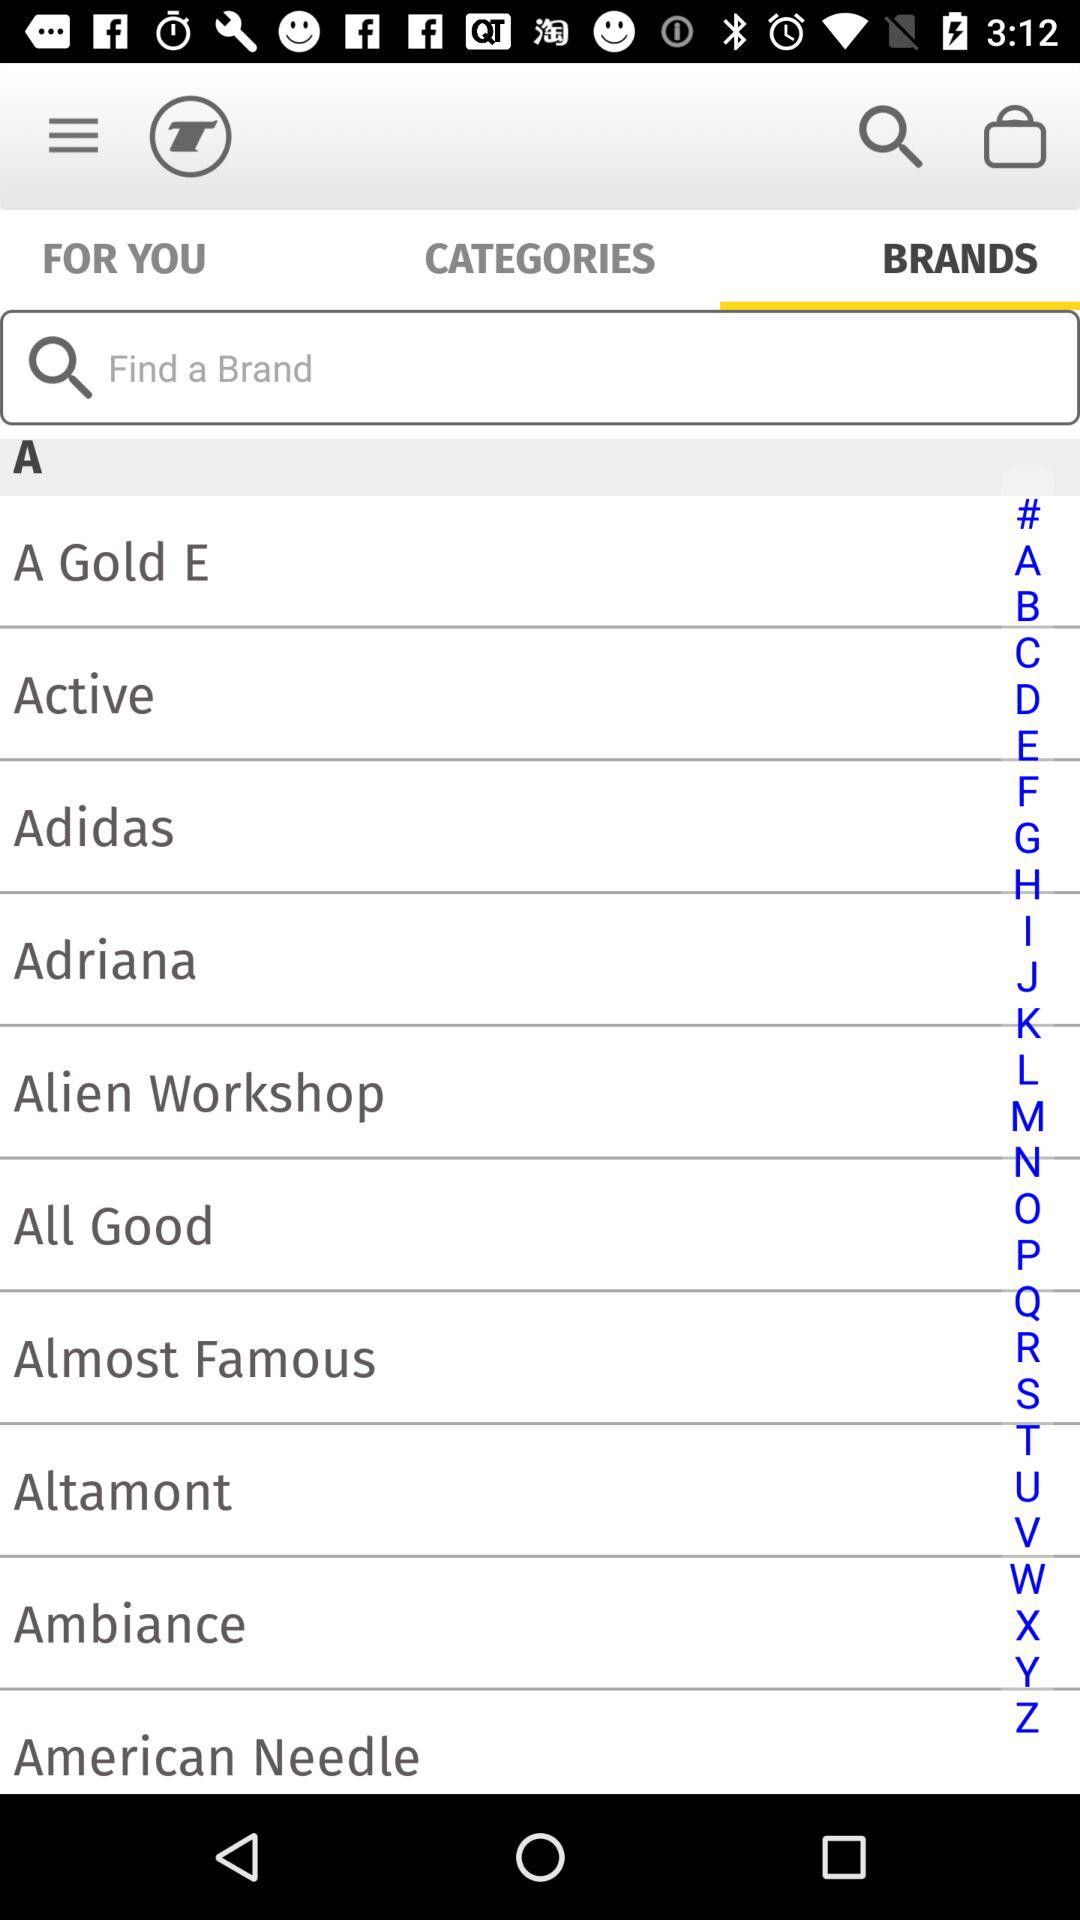Which tab am I on now? You are on the "BRANDS" tab now. 